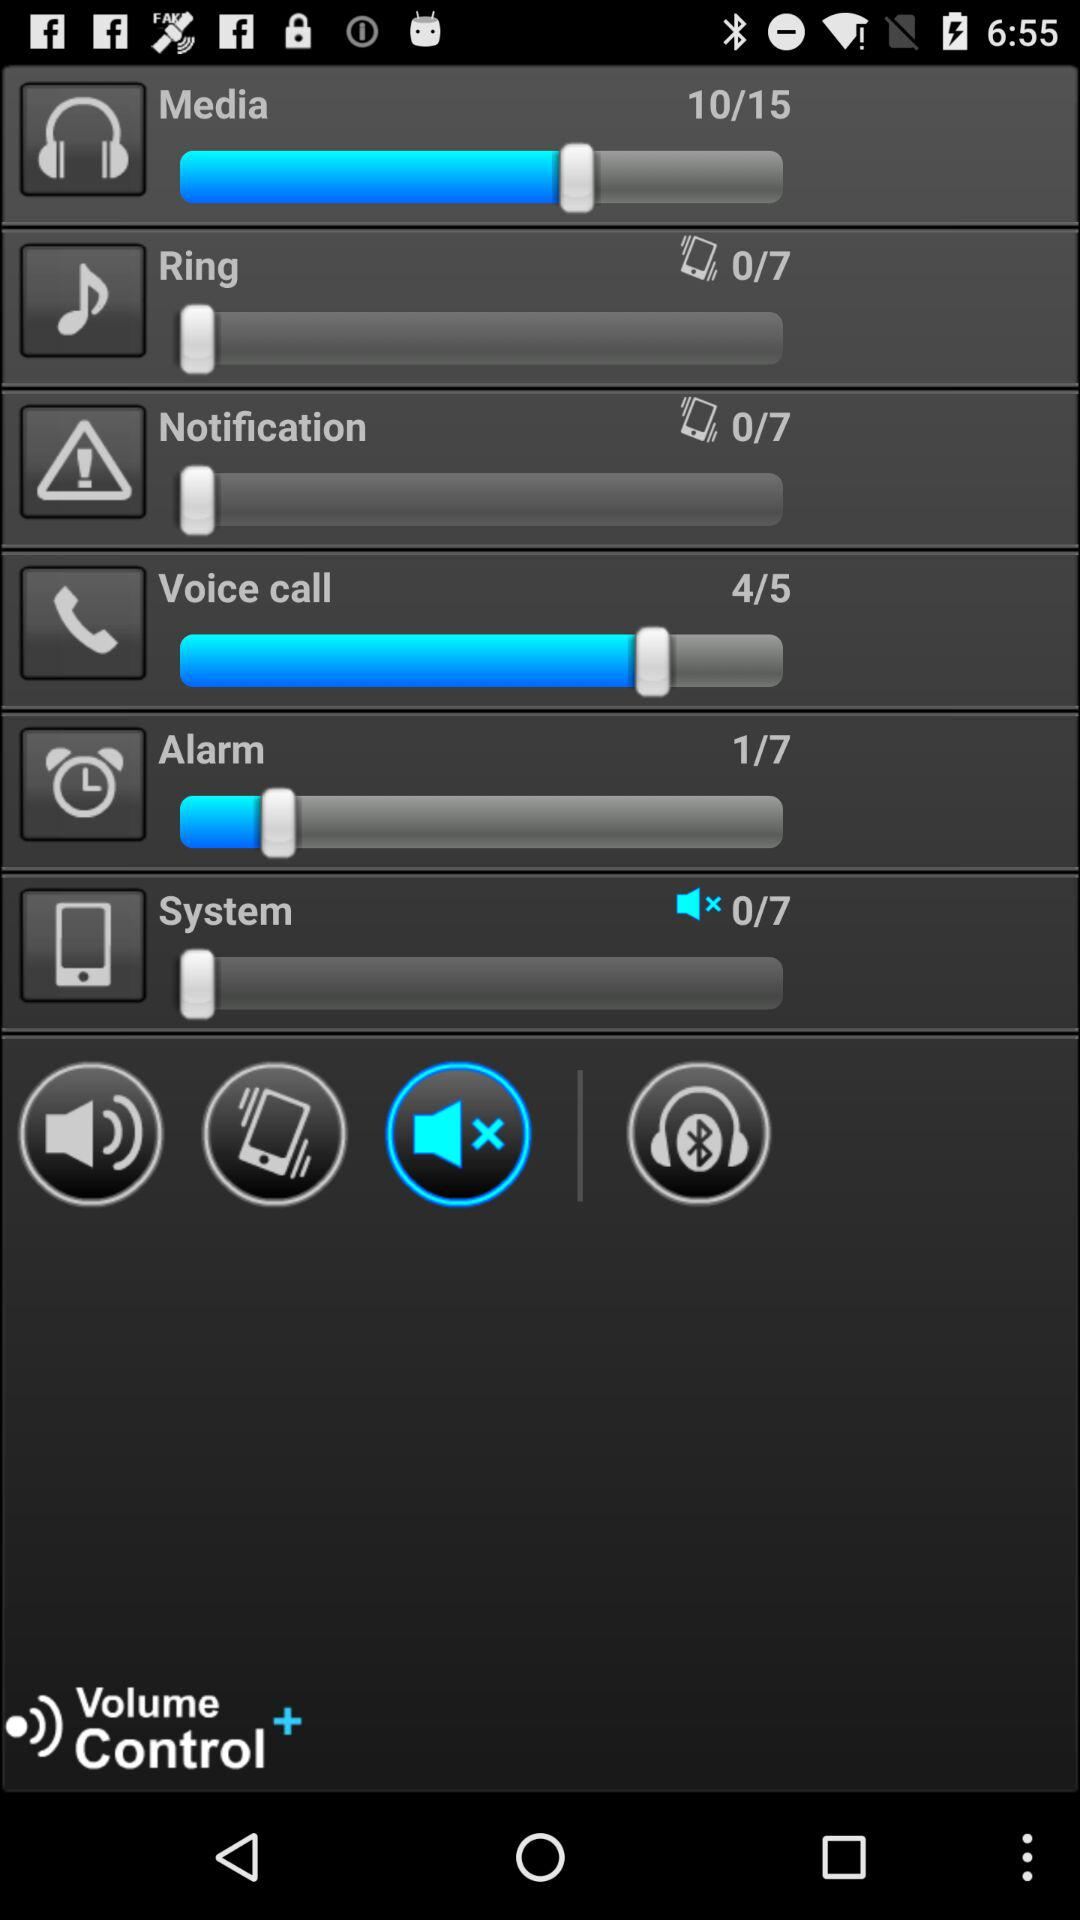Which volume level are we currently using for media? You are currently using media at volume level 10. 